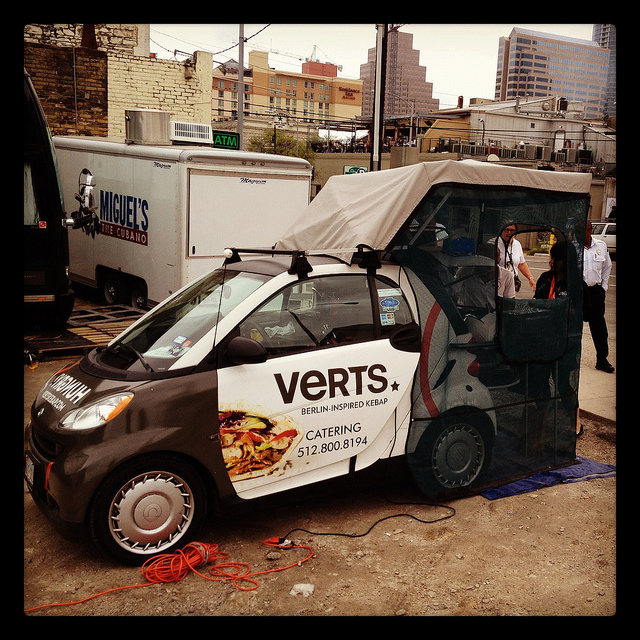Please transcribe the text information in this image. ATM MIGUEL'S Verts KEBAP INSPIRED BERLIN 512.800.8194 CATERING 